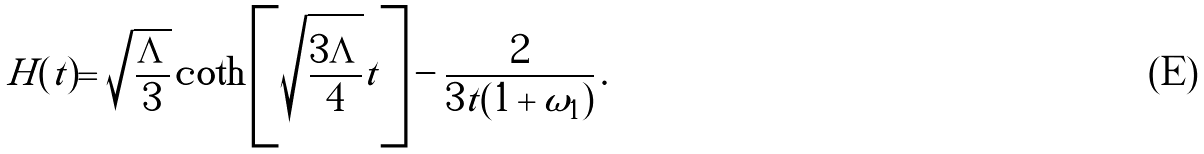Convert formula to latex. <formula><loc_0><loc_0><loc_500><loc_500>\tilde { H } ( t ) = \sqrt { \frac { \Lambda } { 3 } } \coth \left [ \sqrt { \frac { 3 \Lambda } { 4 } } t \right ] - \frac { 2 } { 3 t ( 1 + \omega _ { 1 } ) } \, .</formula> 